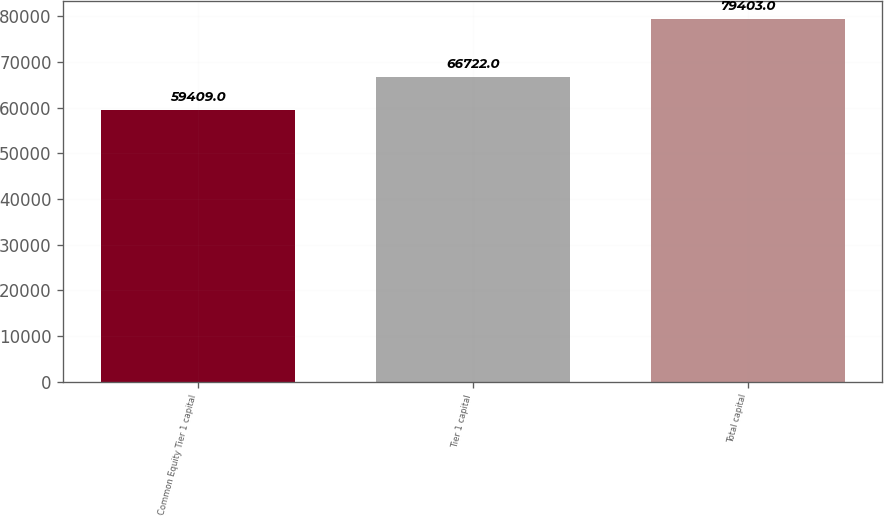Convert chart. <chart><loc_0><loc_0><loc_500><loc_500><bar_chart><fcel>Common Equity Tier 1 capital<fcel>Tier 1 capital<fcel>Total capital<nl><fcel>59409<fcel>66722<fcel>79403<nl></chart> 